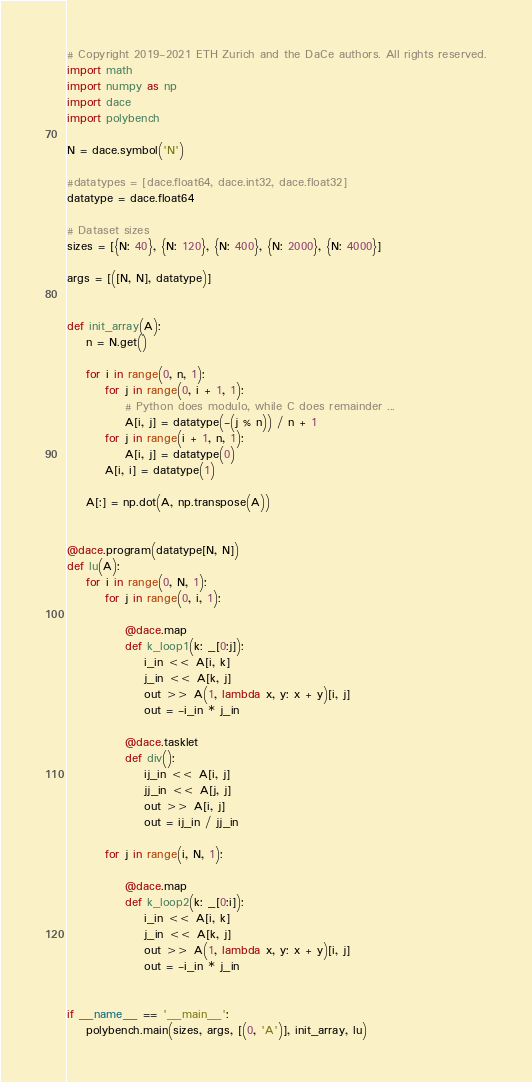Convert code to text. <code><loc_0><loc_0><loc_500><loc_500><_Python_># Copyright 2019-2021 ETH Zurich and the DaCe authors. All rights reserved.
import math
import numpy as np
import dace
import polybench

N = dace.symbol('N')

#datatypes = [dace.float64, dace.int32, dace.float32]
datatype = dace.float64

# Dataset sizes
sizes = [{N: 40}, {N: 120}, {N: 400}, {N: 2000}, {N: 4000}]

args = [([N, N], datatype)]


def init_array(A):
    n = N.get()

    for i in range(0, n, 1):
        for j in range(0, i + 1, 1):
            # Python does modulo, while C does remainder ...
            A[i, j] = datatype(-(j % n)) / n + 1
        for j in range(i + 1, n, 1):
            A[i, j] = datatype(0)
        A[i, i] = datatype(1)

    A[:] = np.dot(A, np.transpose(A))


@dace.program(datatype[N, N])
def lu(A):
    for i in range(0, N, 1):
        for j in range(0, i, 1):

            @dace.map
            def k_loop1(k: _[0:j]):
                i_in << A[i, k]
                j_in << A[k, j]
                out >> A(1, lambda x, y: x + y)[i, j]
                out = -i_in * j_in

            @dace.tasklet
            def div():
                ij_in << A[i, j]
                jj_in << A[j, j]
                out >> A[i, j]
                out = ij_in / jj_in

        for j in range(i, N, 1):

            @dace.map
            def k_loop2(k: _[0:i]):
                i_in << A[i, k]
                j_in << A[k, j]
                out >> A(1, lambda x, y: x + y)[i, j]
                out = -i_in * j_in


if __name__ == '__main__':
    polybench.main(sizes, args, [(0, 'A')], init_array, lu)
</code> 